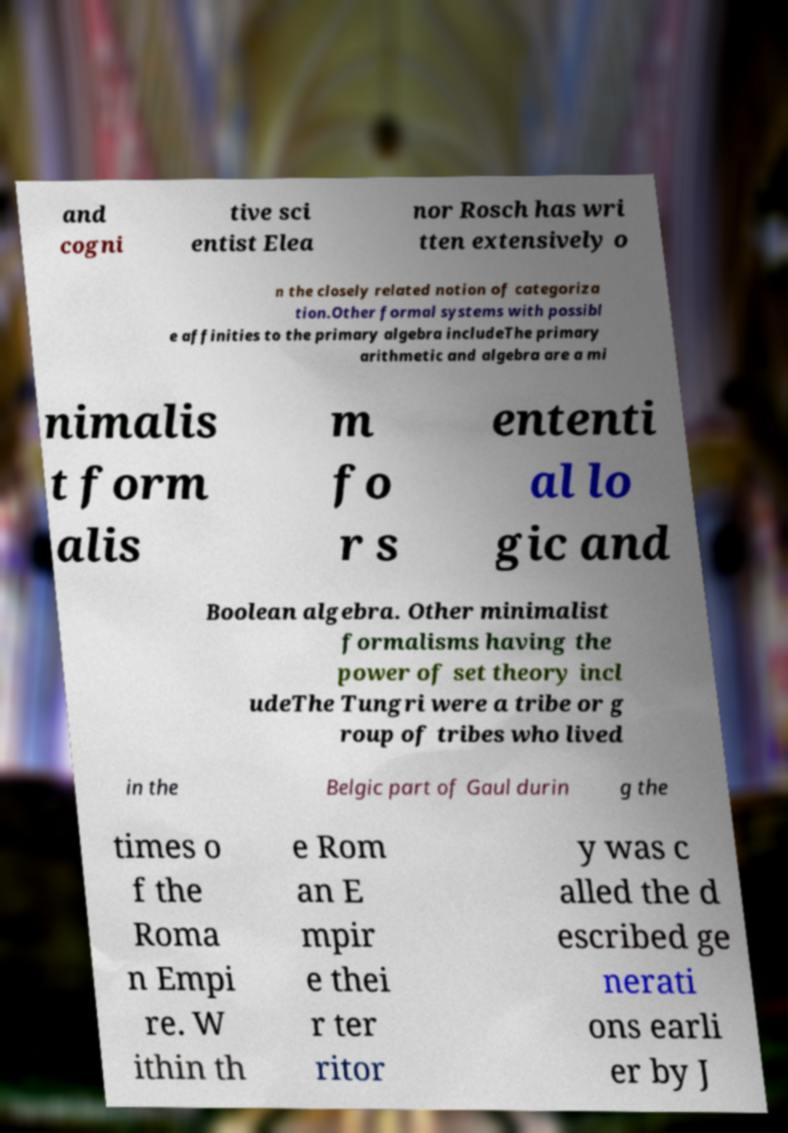I need the written content from this picture converted into text. Can you do that? and cogni tive sci entist Elea nor Rosch has wri tten extensively o n the closely related notion of categoriza tion.Other formal systems with possibl e affinities to the primary algebra includeThe primary arithmetic and algebra are a mi nimalis t form alis m fo r s ententi al lo gic and Boolean algebra. Other minimalist formalisms having the power of set theory incl udeThe Tungri were a tribe or g roup of tribes who lived in the Belgic part of Gaul durin g the times o f the Roma n Empi re. W ithin th e Rom an E mpir e thei r ter ritor y was c alled the d escribed ge nerati ons earli er by J 